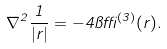<formula> <loc_0><loc_0><loc_500><loc_500>\nabla ^ { 2 } \frac { 1 } { | { r } | } = - 4 \pi \delta ^ { ( 3 ) } ( { r } ) .</formula> 